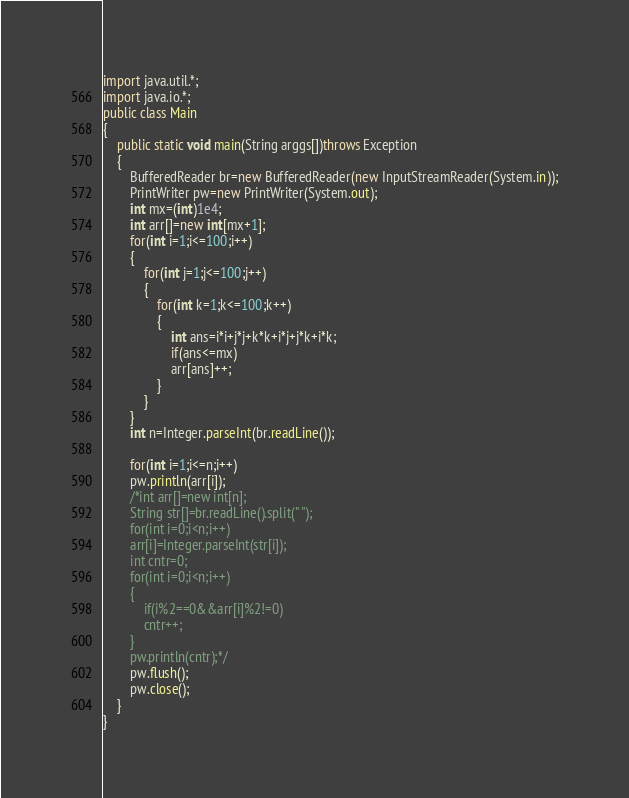Convert code to text. <code><loc_0><loc_0><loc_500><loc_500><_Java_>import java.util.*;
import java.io.*;
public class Main
{
    public static void main(String arggs[])throws Exception
    {
        BufferedReader br=new BufferedReader(new InputStreamReader(System.in));
        PrintWriter pw=new PrintWriter(System.out);
        int mx=(int)1e4;
        int arr[]=new int[mx+1];
        for(int i=1;i<=100;i++)
        {
            for(int j=1;j<=100;j++)
            {
                for(int k=1;k<=100;k++)
                {
                    int ans=i*i+j*j+k*k+i*j+j*k+i*k;
                    if(ans<=mx)
                    arr[ans]++;
                }
            }
        }
        int n=Integer.parseInt(br.readLine());
        
        for(int i=1;i<=n;i++)
        pw.println(arr[i]);
        /*int arr[]=new int[n];
        String str[]=br.readLine().split(" ");
        for(int i=0;i<n;i++)
        arr[i]=Integer.parseInt(str[i]);
        int cntr=0;
        for(int i=0;i<n;i++)
        {
            if(i%2==0&&arr[i]%2!=0)
            cntr++;
        }
        pw.println(cntr);*/
        pw.flush();
        pw.close();
    }
}</code> 